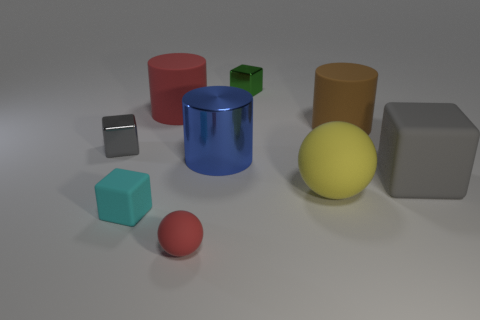Which objects in the image are geometrically perfect and which ones have more complex forms? The geometrically perfect objects include the sphere (yellow ball), the cylinders (blue and brown), and the cubes (teal and green). The gray shapes seem to have slightly more complex forms, with the one on the right possessing beveled edges and the small object on the left having a cut or indentation creating a five-sided figure. 